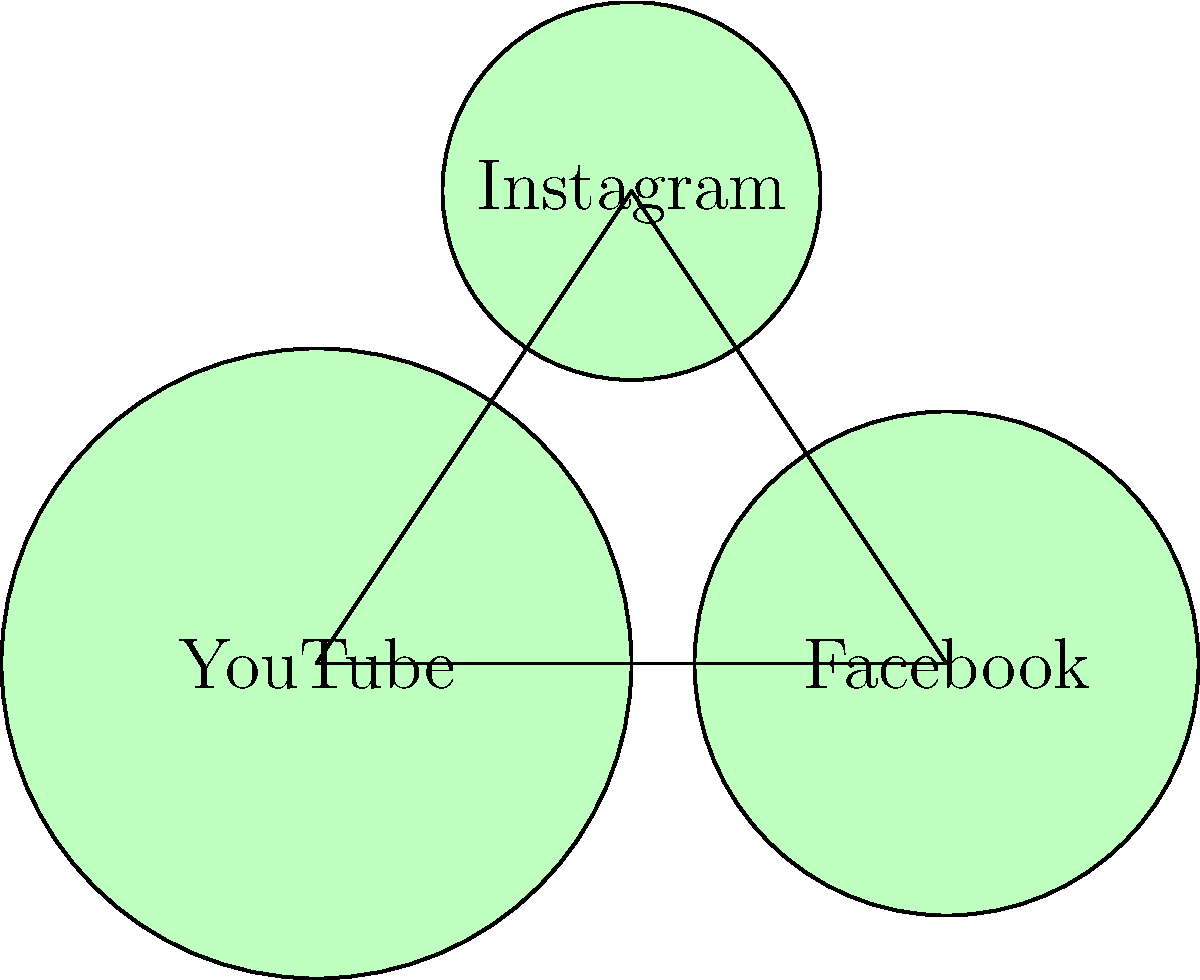Consider the topology of Roddur Roy's fan base distribution across YouTube, Facebook, and Instagram, represented by the connected platforms in the diagram. If each platform is a vertex and the connections between them are edges, what is the Euler characteristic of this network? To find the Euler characteristic of the network, we need to follow these steps:

1. Count the number of vertices (V):
   - YouTube, Facebook, and Instagram are the vertices
   - V = 3

2. Count the number of edges (E):
   - There are connections between YouTube-Facebook, Facebook-Instagram, and Instagram-YouTube
   - E = 3

3. Count the number of faces (F):
   - The triangle formed by the three platforms is the only face
   - F = 1

4. Apply the Euler characteristic formula:
   $$ \chi = V - E + F $$

5. Substitute the values:
   $$ \chi = 3 - 3 + 1 $$

6. Calculate the result:
   $$ \chi = 1 $$

Therefore, the Euler characteristic of Roddur Roy's fan base distribution network is 1.
Answer: 1 